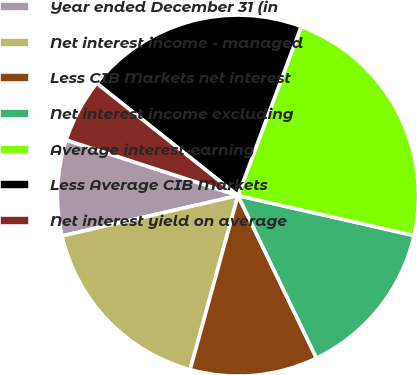Convert chart. <chart><loc_0><loc_0><loc_500><loc_500><pie_chart><fcel>Year ended December 31 (in<fcel>Net interest income - managed<fcel>Less CIB Markets net interest<fcel>Net interest income excluding<fcel>Average interest-earning<fcel>Less Average CIB Markets<fcel>Net interest yield on average<nl><fcel>8.57%<fcel>17.14%<fcel>11.43%<fcel>14.29%<fcel>22.86%<fcel>20.0%<fcel>5.71%<nl></chart> 